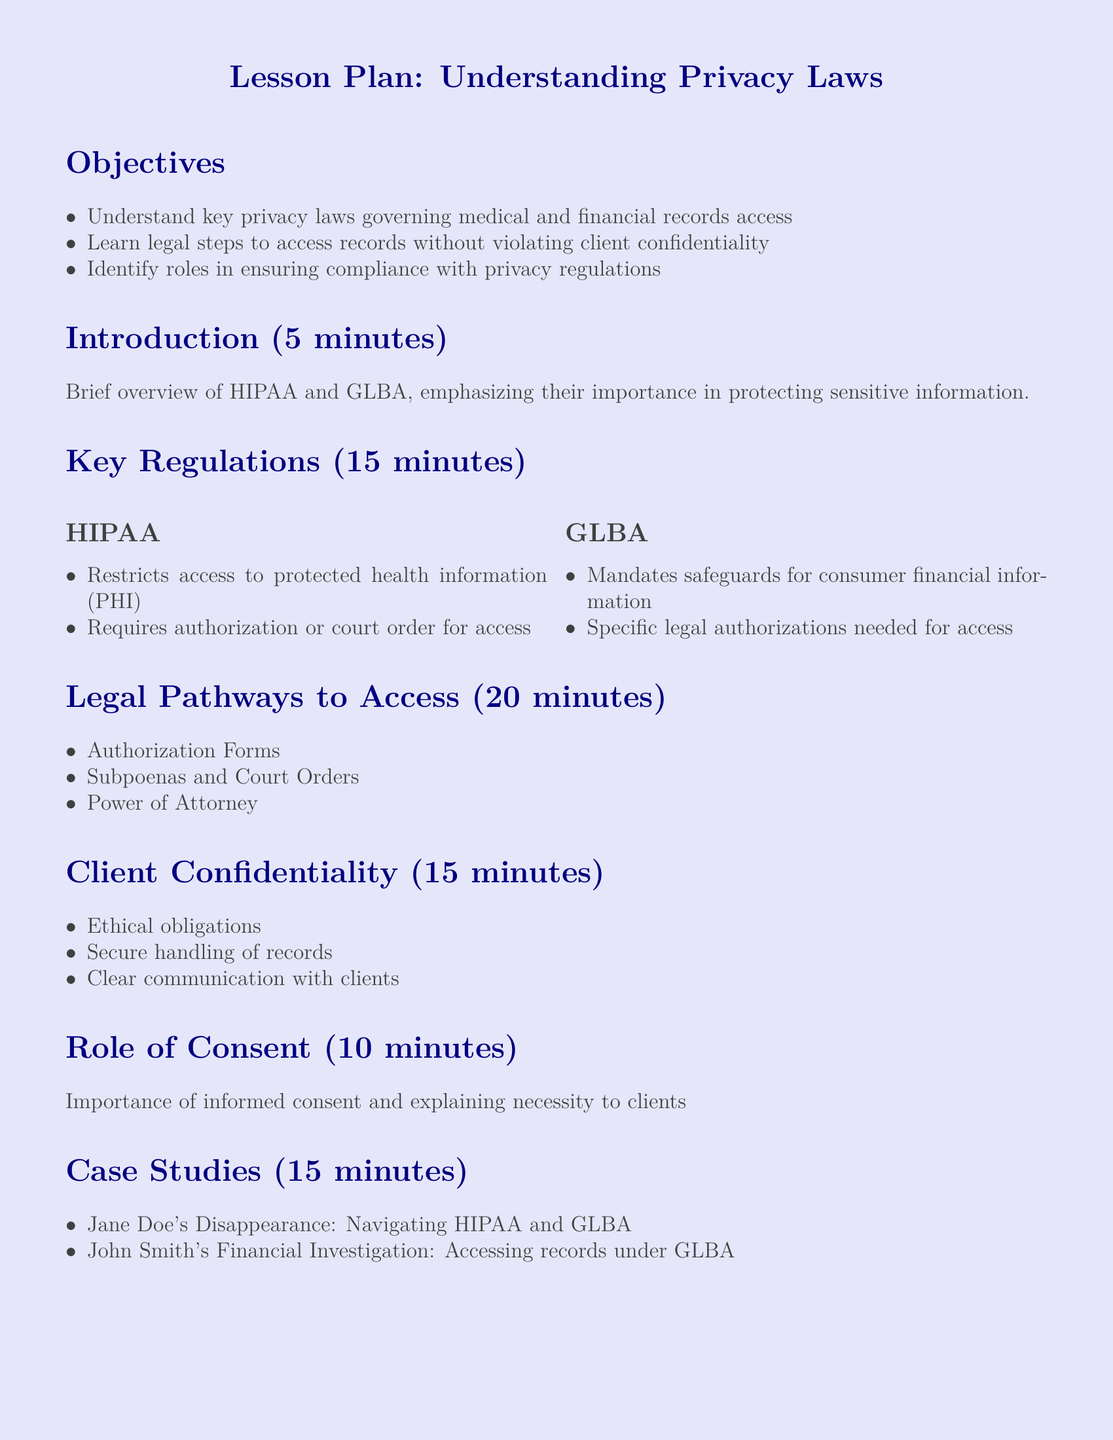what is the main objective of the lesson plan? The main objectives are outlined in the Objectives section, specifically focusing on understanding privacy laws and legal access to records.
Answer: Understand key privacy laws governing medical and financial records access what are the two key regulations highlighted in the lesson? The Key Regulations section lists HIPAA and GLBA as the two important regulations.
Answer: HIPAA and GLBA what type of records does HIPAA restrict access to? HIPAA's restrictions pertain specifically to protected health information, as stated in the Key Regulations section.
Answer: protected health information (PHI) how long is the introduction segment? The duration of the Introduction section is detailed in the document, which specifies that it lasts 5 minutes.
Answer: 5 minutes which method is mentioned for accessing records under GLBA? The Legal Pathways to Access section mentions subpoenas and court orders as methods to access records.
Answer: Subpoenas and Court Orders what ethical obligation is mentioned in relation to client confidentiality? The Client Confidentiality section discusses ethical obligations as part of handling records securely.
Answer: Ethical obligations what case study is used to illustrate navigating HIPAA? The Case Studies section specifically names Jane Doe’s disappearance as an illustration related to HIPAA navigation.
Answer: Jane Doe's Disappearance how many minutes are designated for the Best Practices section? The duration set for the Best Practices section is mentioned as 10 minutes.
Answer: 10 minutes 